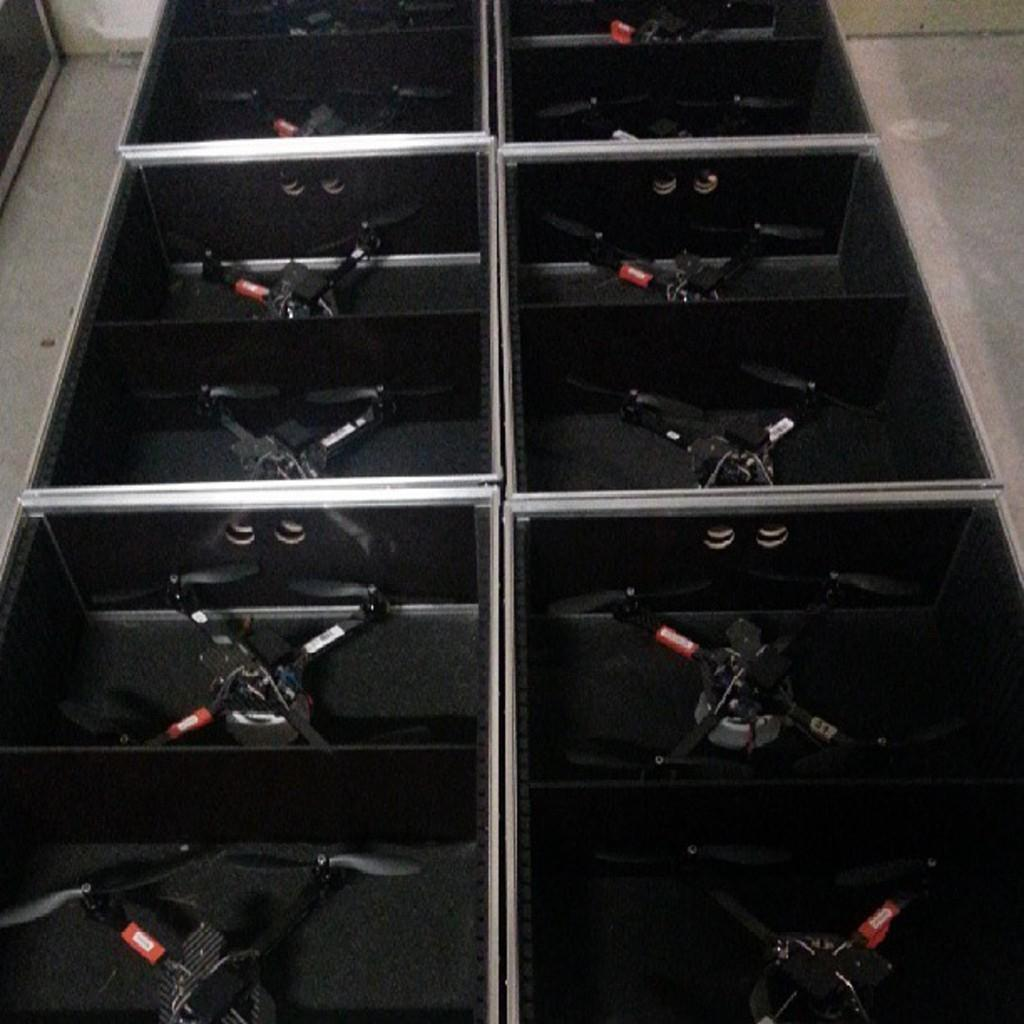What is inside the boxes in the image? There are objects in the boxes. Can you describe the location of the boxes in the image? The boxes are on a surface. What is the weight of the beetle crawling on the boxes in the image? There is no beetle present in the image, so it is not possible to determine its weight. 